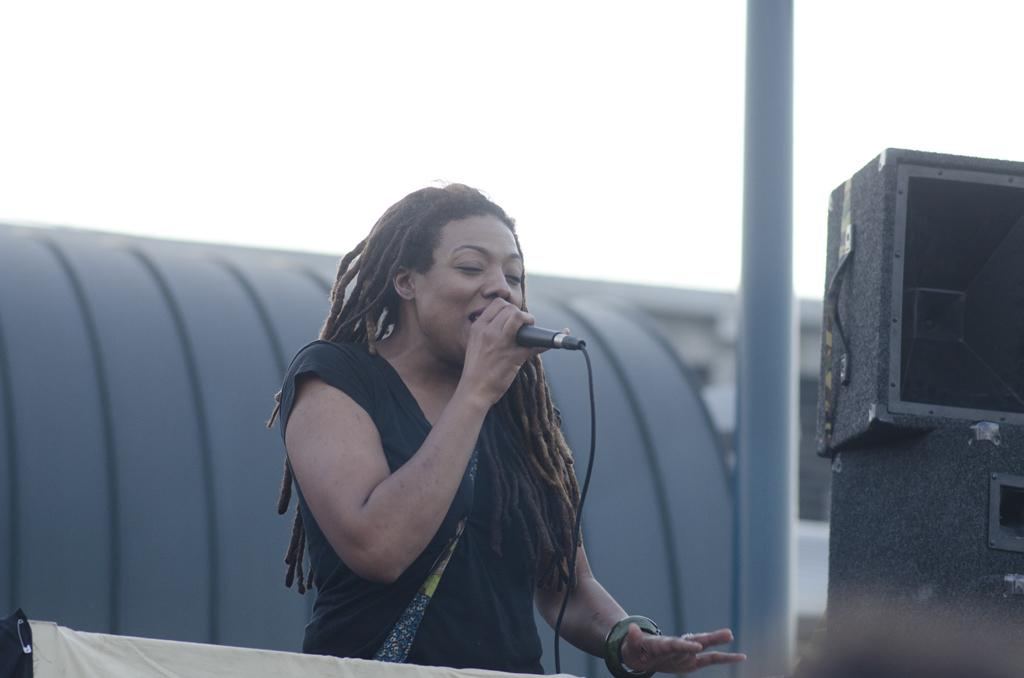Who is the main subject in the image? There is a woman in the image. What is the woman doing in the image? The woman is standing and singing. What object is the woman holding in her hand? The woman is holding a microphone in her hand. What type of recess is visible in the image? There is no recess present in the image. How does the woman use the microphone in the image? The woman is using the microphone to sing, as she is holding it in her hand while singing. 